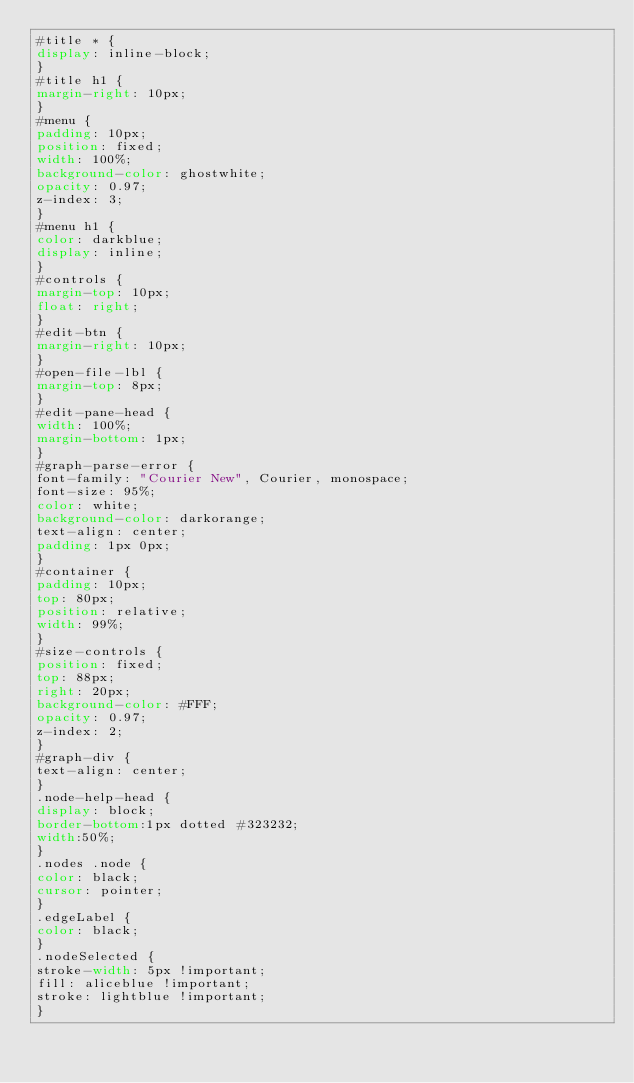<code> <loc_0><loc_0><loc_500><loc_500><_CSS_>#title * {
display: inline-block;
}
#title h1 {
margin-right: 10px;
}
#menu {
padding: 10px;
position: fixed;
width: 100%;
background-color: ghostwhite;
opacity: 0.97;
z-index: 3;
}
#menu h1 {
color: darkblue;
display: inline;
}
#controls {
margin-top: 10px;
float: right;
}
#edit-btn {
margin-right: 10px;
}
#open-file-lbl {
margin-top: 8px;
}
#edit-pane-head {
width: 100%;
margin-bottom: 1px;
}
#graph-parse-error {
font-family: "Courier New", Courier, monospace;
font-size: 95%;
color: white;
background-color: darkorange;
text-align: center;
padding: 1px 0px;
}
#container {
padding: 10px;
top: 80px;
position: relative;
width: 99%;
}
#size-controls {
position: fixed;
top: 88px;
right: 20px;
background-color: #FFF;
opacity: 0.97;
z-index: 2;
}
#graph-div {
text-align: center;
}
.node-help-head {
display: block;
border-bottom:1px dotted #323232;
width:50%;
}
.nodes .node {
color: black;
cursor: pointer;
}
.edgeLabel {
color: black;
}
.nodeSelected {
stroke-width: 5px !important;
fill: aliceblue !important;
stroke: lightblue !important;
}</code> 